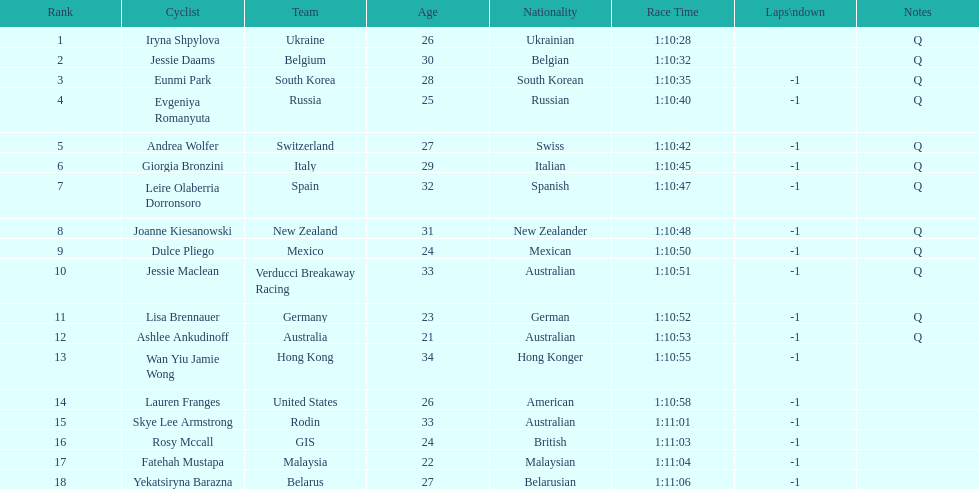What two cyclists come from teams with no laps down? Iryna Shpylova, Jessie Daams. 